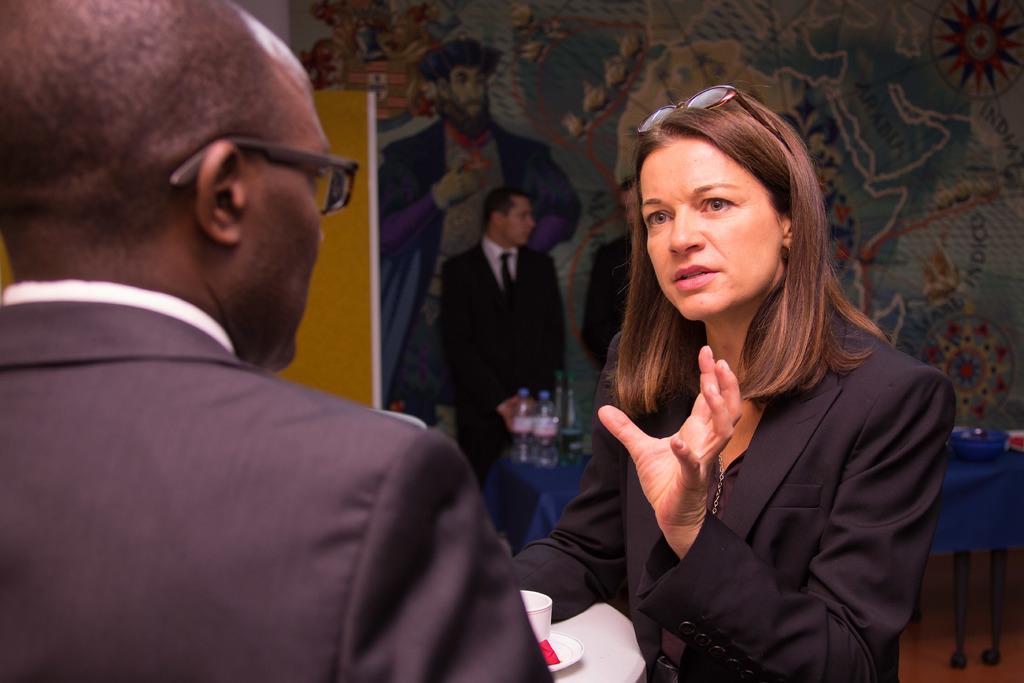How would you summarize this image in a sentence or two? In the picture I can see a man and woman wearing black color dress discussing between themselves and in the background of the picture there is a person wearing black color suit standing behind table on which there are some bottles and other things, there is a wall which is painted of different images. 